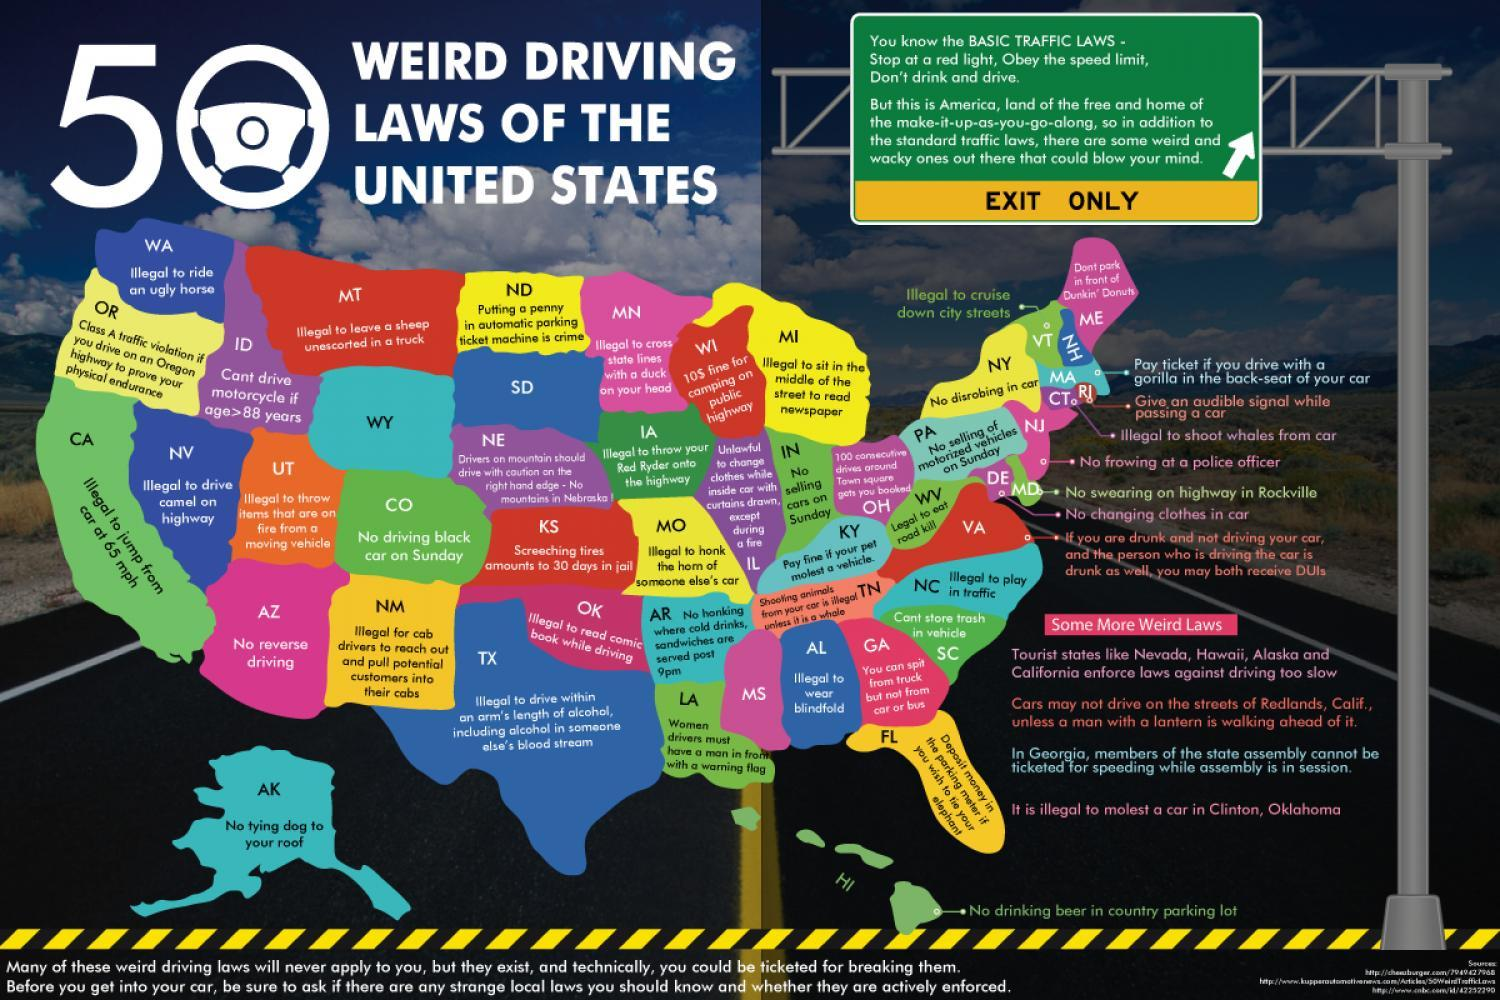Which weird law prevails in MD?
Answer the question with a short phrase. no searing on highway in rockville What is the weird driving law prevailing in IA? illegal to throw your red ryder onto the highway 